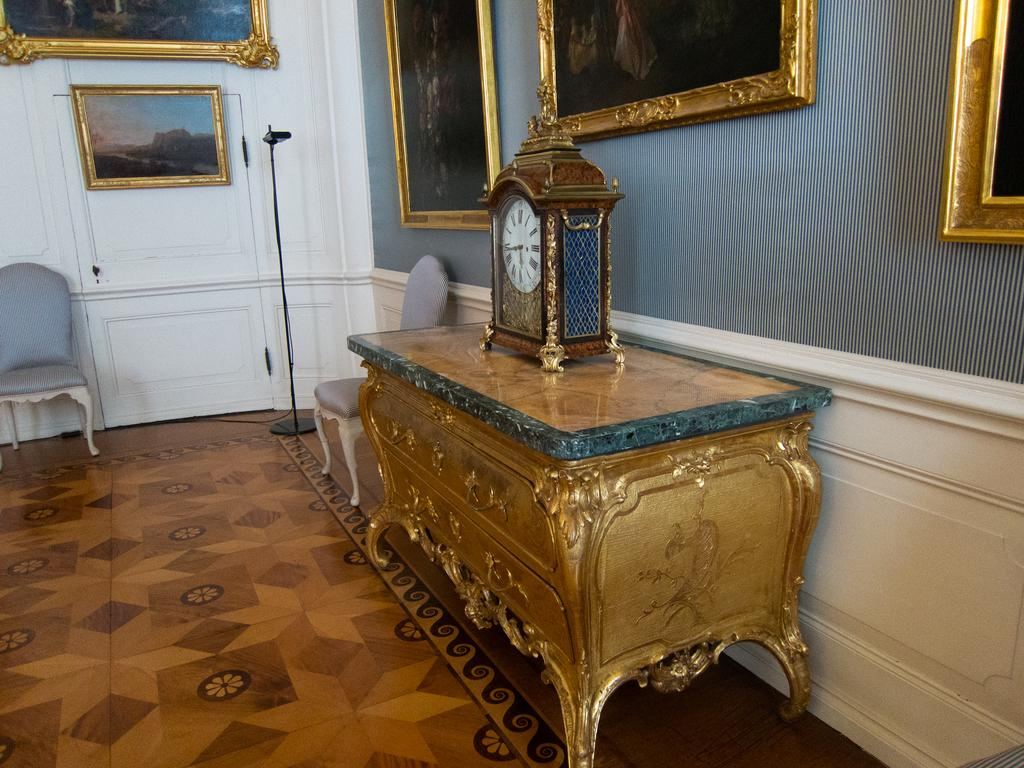What type of space is depicted in the image? There is a room in the image. What furniture is present in the room? There are chairs, a table, and a pole in the room. How can one enter or exit the room? There is a door in the room for entering or exiting. What object is placed on the table in the room? There is a watch on the table. What decorative elements are present on the walls in the background? There are frames on the wall in the background. Can you tell me how many hens are sitting on the pole in the image? There are no hens present in the image; the pole is a structural element in the room. What type of snake can be seen slithering across the table in the image? There are no snakes present in the image; the table only has a watch on it. 